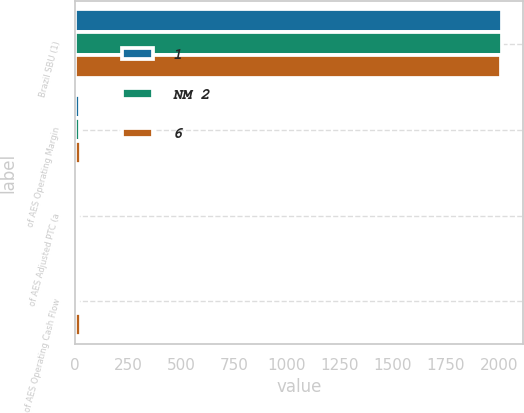Convert chart to OTSL. <chart><loc_0><loc_0><loc_500><loc_500><stacked_bar_chart><ecel><fcel>Brazil SBU (1)<fcel>of AES Operating Margin<fcel>of AES Adjusted PTC (a<fcel>of AES Operating Cash Flow<nl><fcel>1<fcel>2015<fcel>21<fcel>6<fcel>5<nl><fcel>NM 2<fcel>2014<fcel>24<fcel>13<fcel>14<nl><fcel>6<fcel>2013<fcel>27<fcel>12<fcel>26<nl></chart> 